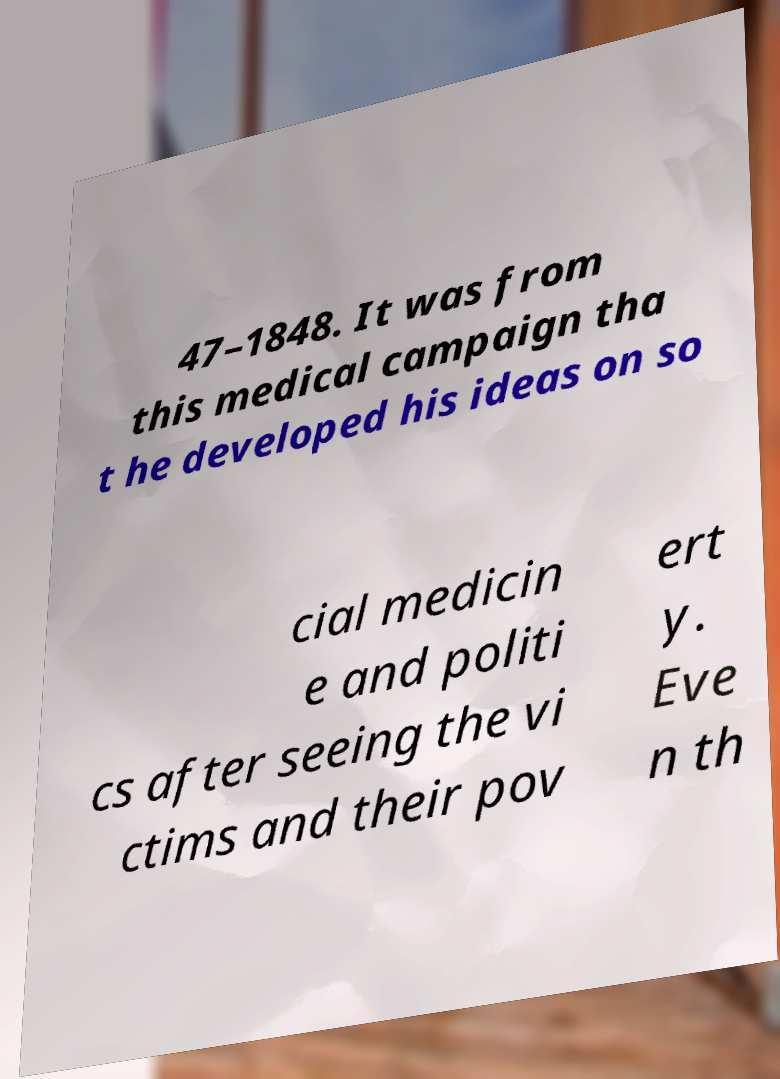For documentation purposes, I need the text within this image transcribed. Could you provide that? 47–1848. It was from this medical campaign tha t he developed his ideas on so cial medicin e and politi cs after seeing the vi ctims and their pov ert y. Eve n th 